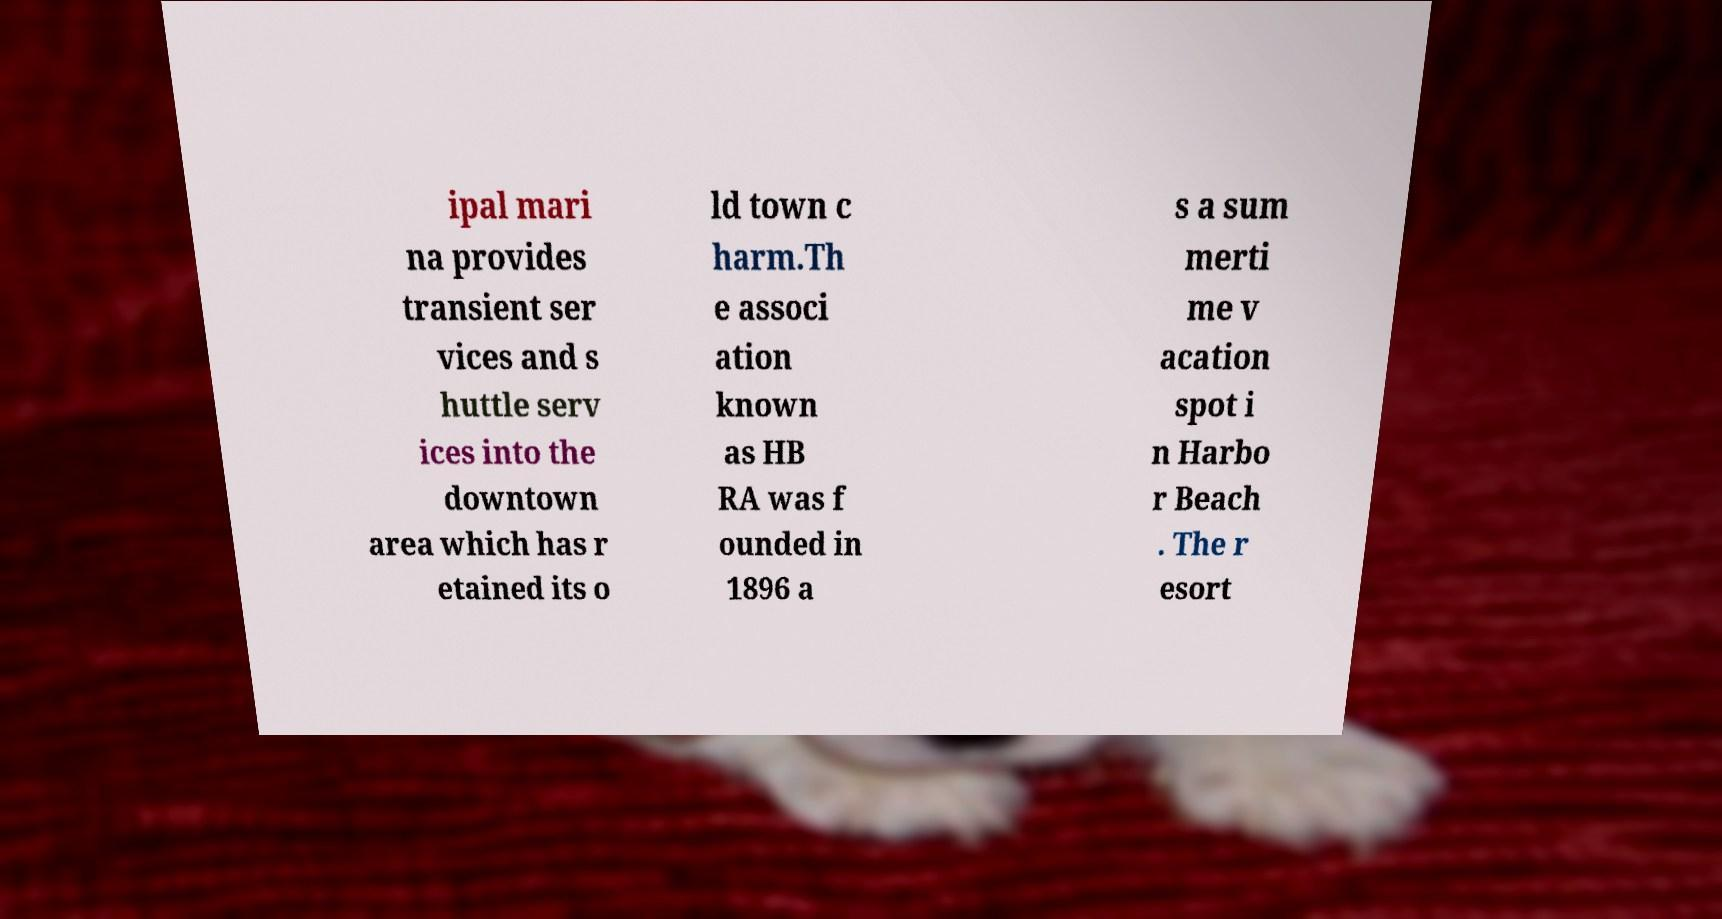For documentation purposes, I need the text within this image transcribed. Could you provide that? ipal mari na provides transient ser vices and s huttle serv ices into the downtown area which has r etained its o ld town c harm.Th e associ ation known as HB RA was f ounded in 1896 a s a sum merti me v acation spot i n Harbo r Beach . The r esort 